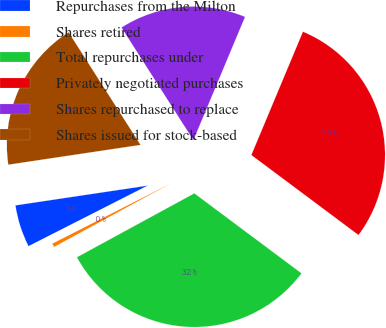Convert chart to OTSL. <chart><loc_0><loc_0><loc_500><loc_500><pie_chart><fcel>Repurchases from the Milton<fcel>Shares retired<fcel>Total repurchases under<fcel>Privately negotiated purchases<fcel>Shares repurchased to replace<fcel>Shares issued for stock-based<nl><fcel>5.12%<fcel>0.45%<fcel>31.86%<fcel>28.9%<fcel>15.35%<fcel>18.32%<nl></chart> 